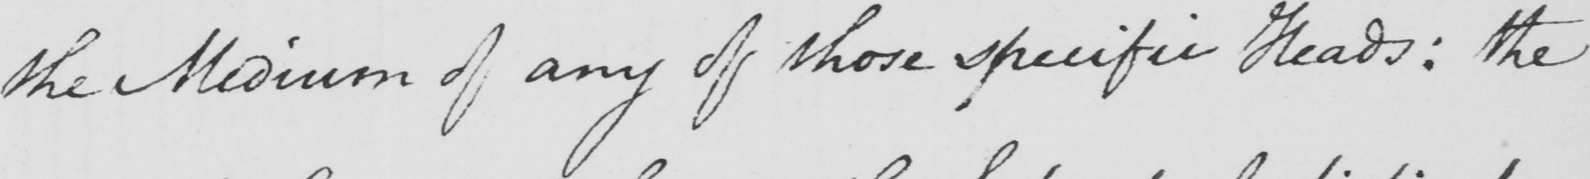Please provide the text content of this handwritten line. the Medium of any of those specific Heads: the 